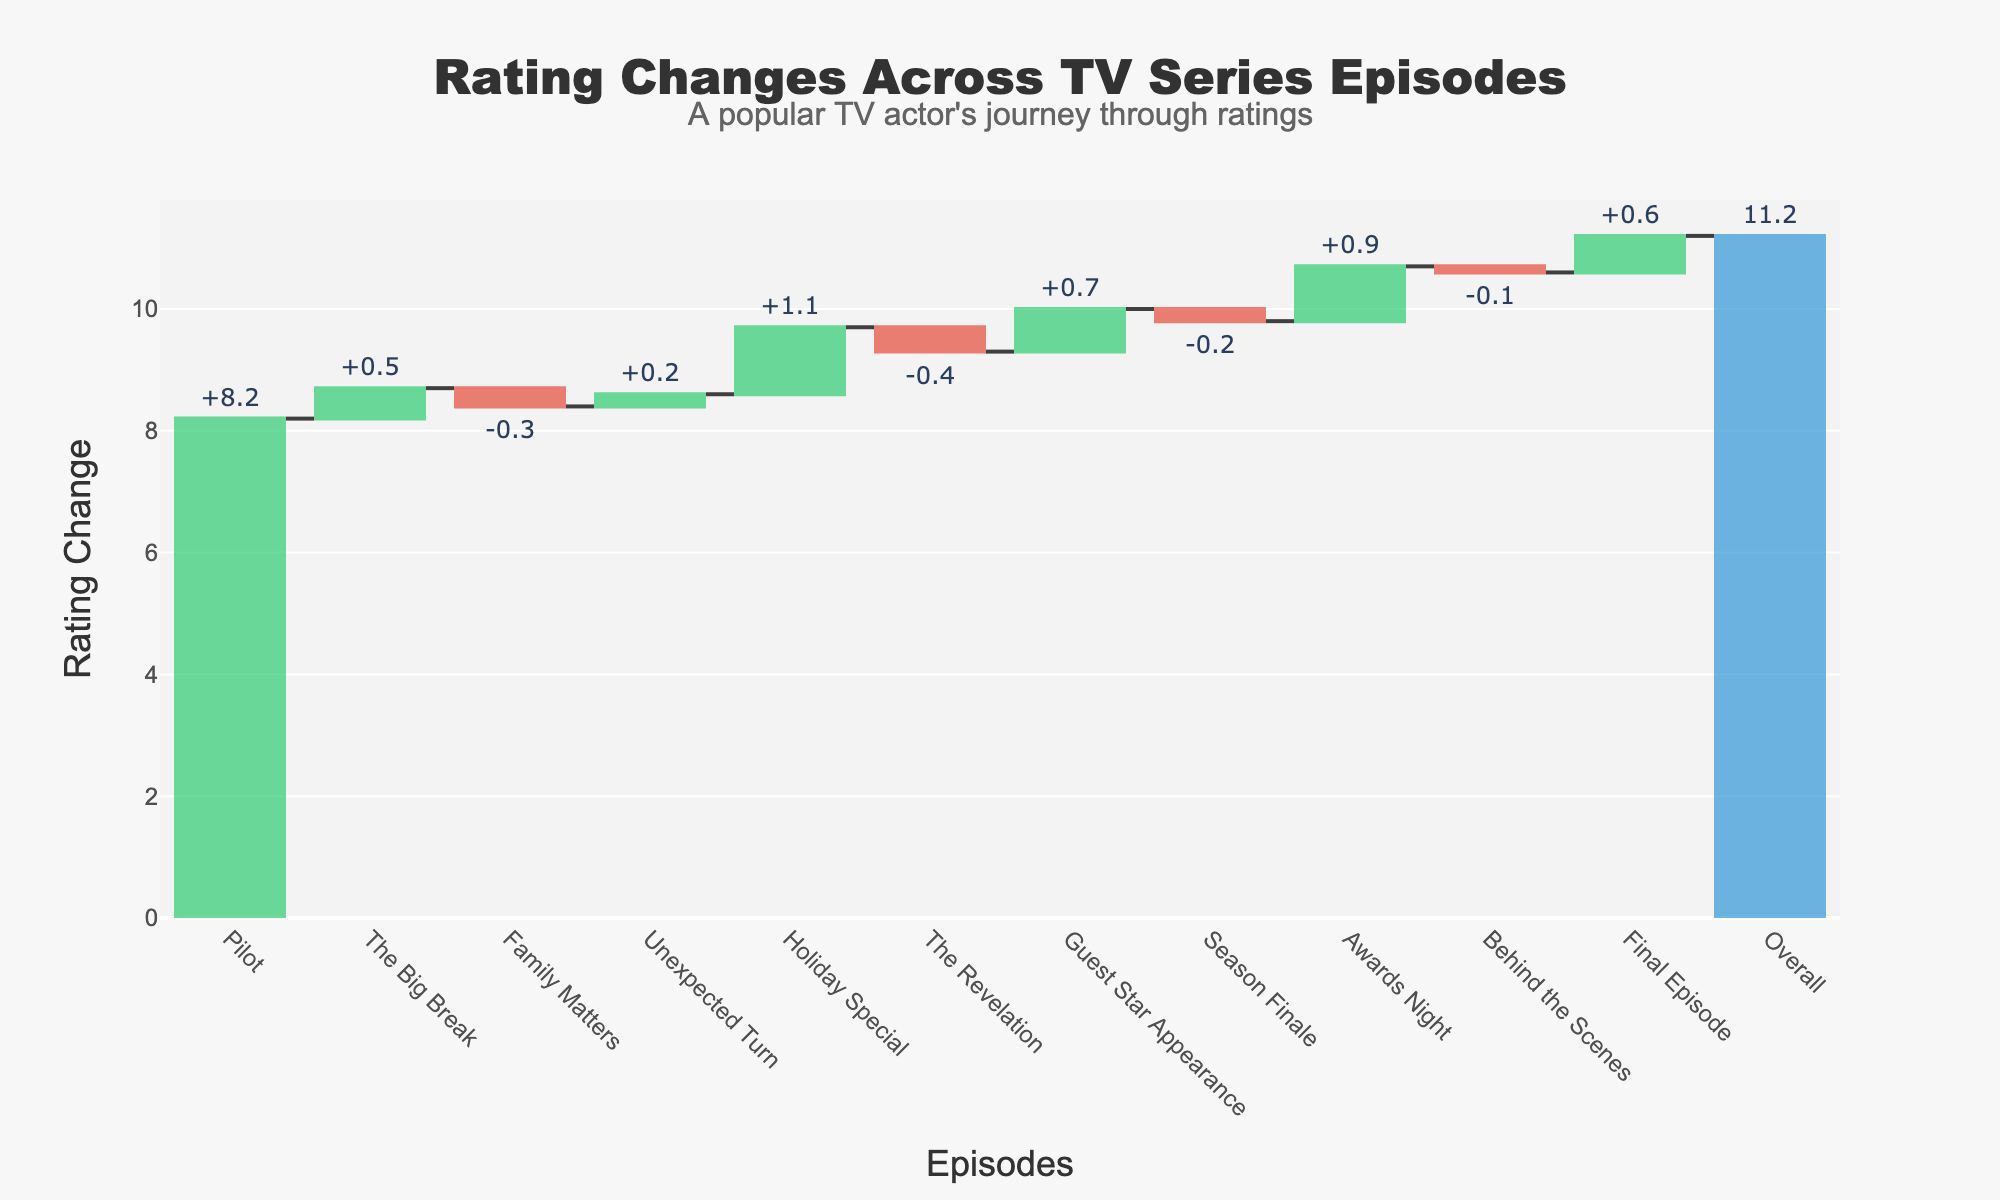How many episodes showed an increase in ratings? The green bars in the chart represent the episodes with increased ratings. Count the number of green bars to find the answer.
Answer: 6 What is the overall change in ratings from the "Pilot" episode to the "Final Episode"? Look at the total cumulative change from the starting point (Pilot) to the end point (Final Episode). This can be found in the "Overall" section of the chart, shown as a total value.
Answer: 11.2 Which episode had the highest drop in ratings? Identify the longest red bar in the waterfall chart, which marks the episode with the largest negative change.
Answer: "The Revelation" How much did the ratings change in the "Holiday Special"? Find the text next to the "Holiday Special" bar and note the change, which is positive as indicated by green.
Answer: +1.1 What is the cumulative rating change after the "Guest Star Appearance" episode? Add all rating changes up to and including the "Guest Star Appearance". This can be viewed directly by noting the cumulative sum at the top of the bar for that episode.
Answer: +10.0 Which episodes had a rating change exactly equal to -0.1? Identify episodes marked with red bars where the change is equal to -0.1.
Answer: "Behind the Scenes" Compare the rating increase for "The Big Break" and "Holiday Special". Which one had a larger increase? Calculate the increases for both episodes and compare them. Find the exact change next to each bar and note that one is larger.
Answer: "Holiday Special" What was the rating change for the "Season Finale"? The change in ratings can be read directly from the text next to the Season Finale's bar.
Answer: -0.2 Calculate the sum of rating changes for episodes with a positive change in ratings. Sum up the rating changes indicated by green bars, or simply add the positive changes identified in the figure.
Answer: 4.0 How did the "Awards Night" affect the overall rating in terms of increase percentage, considering the starting point at "Pilot"? Calculate the increase percentage by dividing the change for "Awards Night" by the initial rating from "Pilot", and then multiplying by 100.
Answer: (0.9 / 8.2) * 100 = 10.98% 